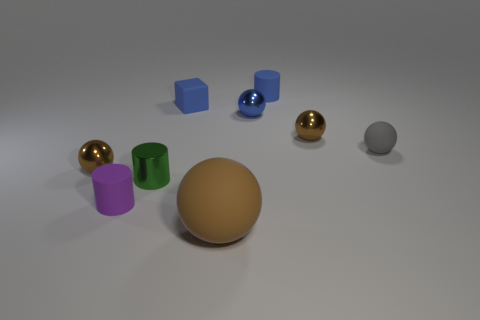Do the tiny rubber sphere and the tiny cube have the same color? no 